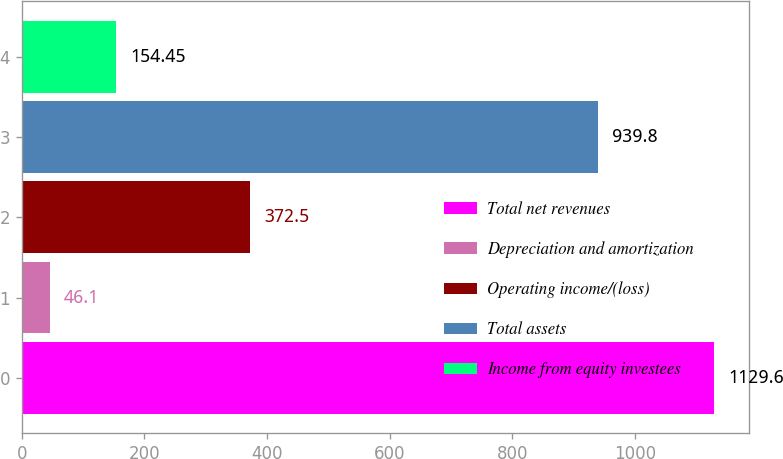<chart> <loc_0><loc_0><loc_500><loc_500><bar_chart><fcel>Total net revenues<fcel>Depreciation and amortization<fcel>Operating income/(loss)<fcel>Total assets<fcel>Income from equity investees<nl><fcel>1129.6<fcel>46.1<fcel>372.5<fcel>939.8<fcel>154.45<nl></chart> 